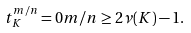Convert formula to latex. <formula><loc_0><loc_0><loc_500><loc_500>t ^ { m / n } _ { K } = 0 m / n \geq 2 \nu ( K ) - 1 .</formula> 